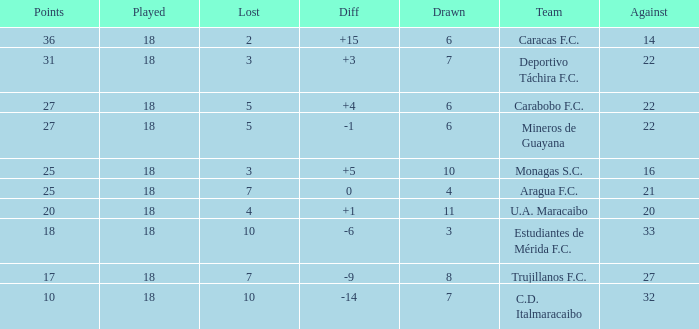What is the average against score of all teams with less than 7 losses, more than 6 draws, and 25 points? 16.0. 